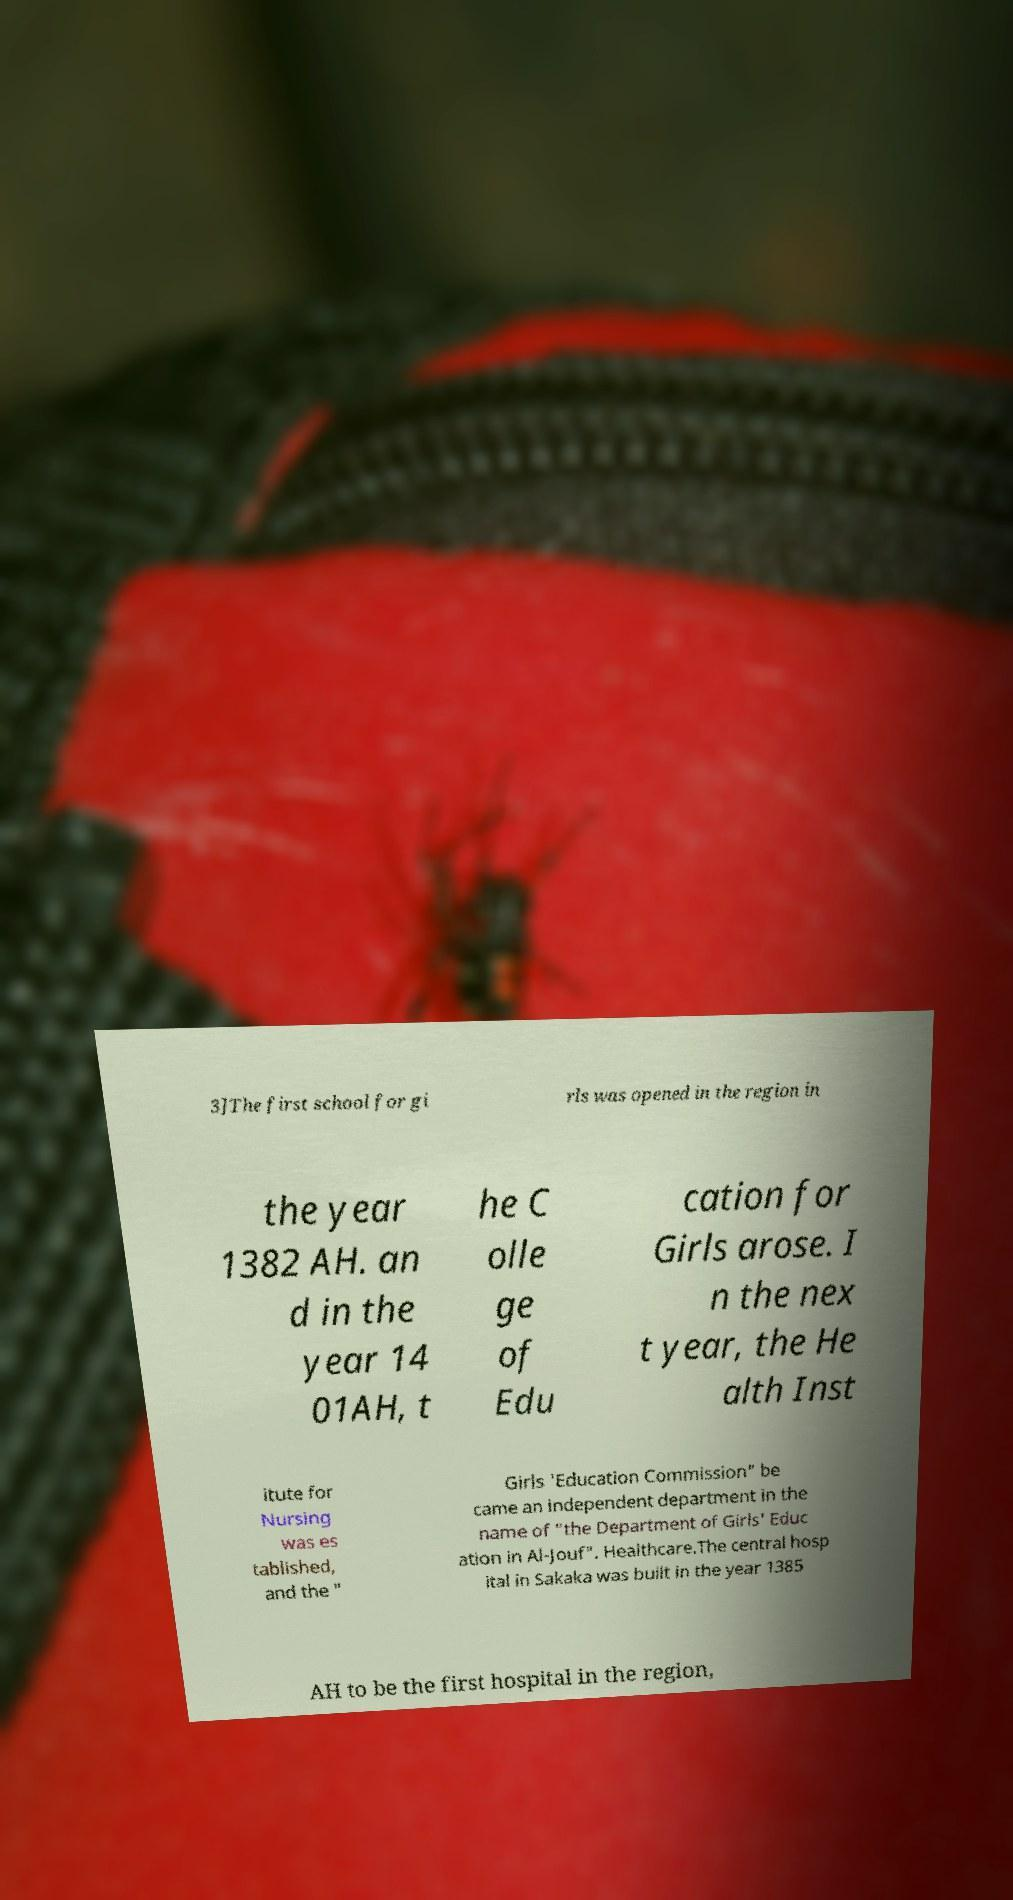What messages or text are displayed in this image? I need them in a readable, typed format. 3]The first school for gi rls was opened in the region in the year 1382 AH. an d in the year 14 01AH, t he C olle ge of Edu cation for Girls arose. I n the nex t year, the He alth Inst itute for Nursing was es tablished, and the " Girls 'Education Commission" be came an independent department in the name of "the Department of Girls' Educ ation in Al-Jouf". Healthcare.The central hosp ital in Sakaka was built in the year 1385 AH to be the first hospital in the region, 